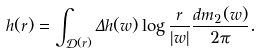<formula> <loc_0><loc_0><loc_500><loc_500>h ( r ) = \int _ { \mathcal { D } ( r ) } \Delta h ( w ) \log \frac { r } { | w | } \frac { d m _ { 2 } ( w ) } { 2 \pi } .</formula> 